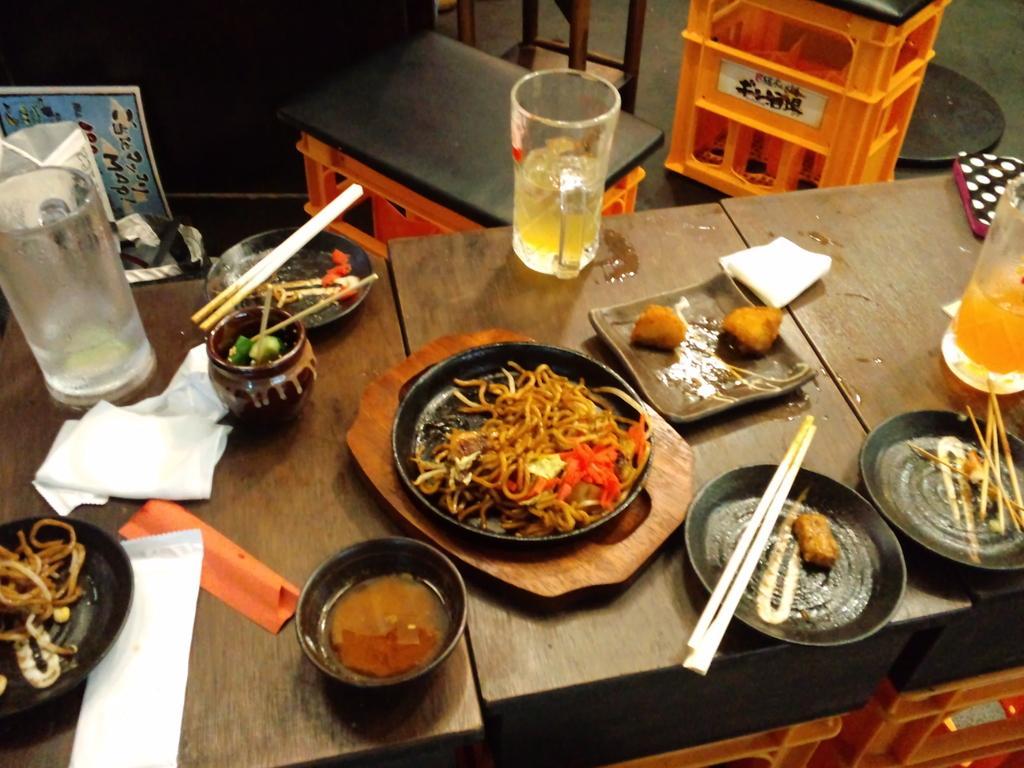In one or two sentences, can you explain what this image depicts? In this picture we can see table and on table we have bowl, plate, jar, chopstick, pot, glass, tissue paper and some food in it and aside to this we have poster and stool. 